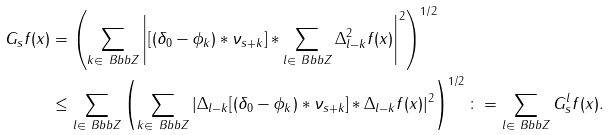<formula> <loc_0><loc_0><loc_500><loc_500>G _ { s } f ( x ) & = \left ( \sum _ { k \in \ B b b Z } \left | [ ( \delta _ { 0 } - \phi _ { k } ) \ast \nu _ { s + k } ] \ast \sum _ { l \in \ B b b Z } \Delta _ { l - k } ^ { 2 } f ( x ) \right | ^ { 2 } \right ) ^ { 1 / 2 } \\ & \leq \sum _ { l \in \ B b b Z } \left ( \sum _ { k \in \ B b b Z } | \Delta _ { l - k } [ ( \delta _ { 0 } - \phi _ { k } ) \ast \nu _ { s + k } ] \ast \Delta _ { l - k } f ( x ) | ^ { 2 } \right ) ^ { 1 / 2 } \colon = \sum _ { l \in \ B b b Z } G _ { s } ^ { l } f ( x ) .</formula> 